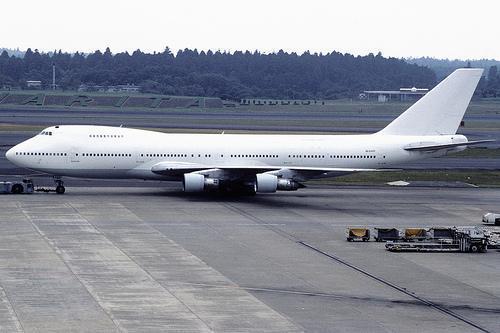How many 'A's are on the hill?
Give a very brief answer. 2. 